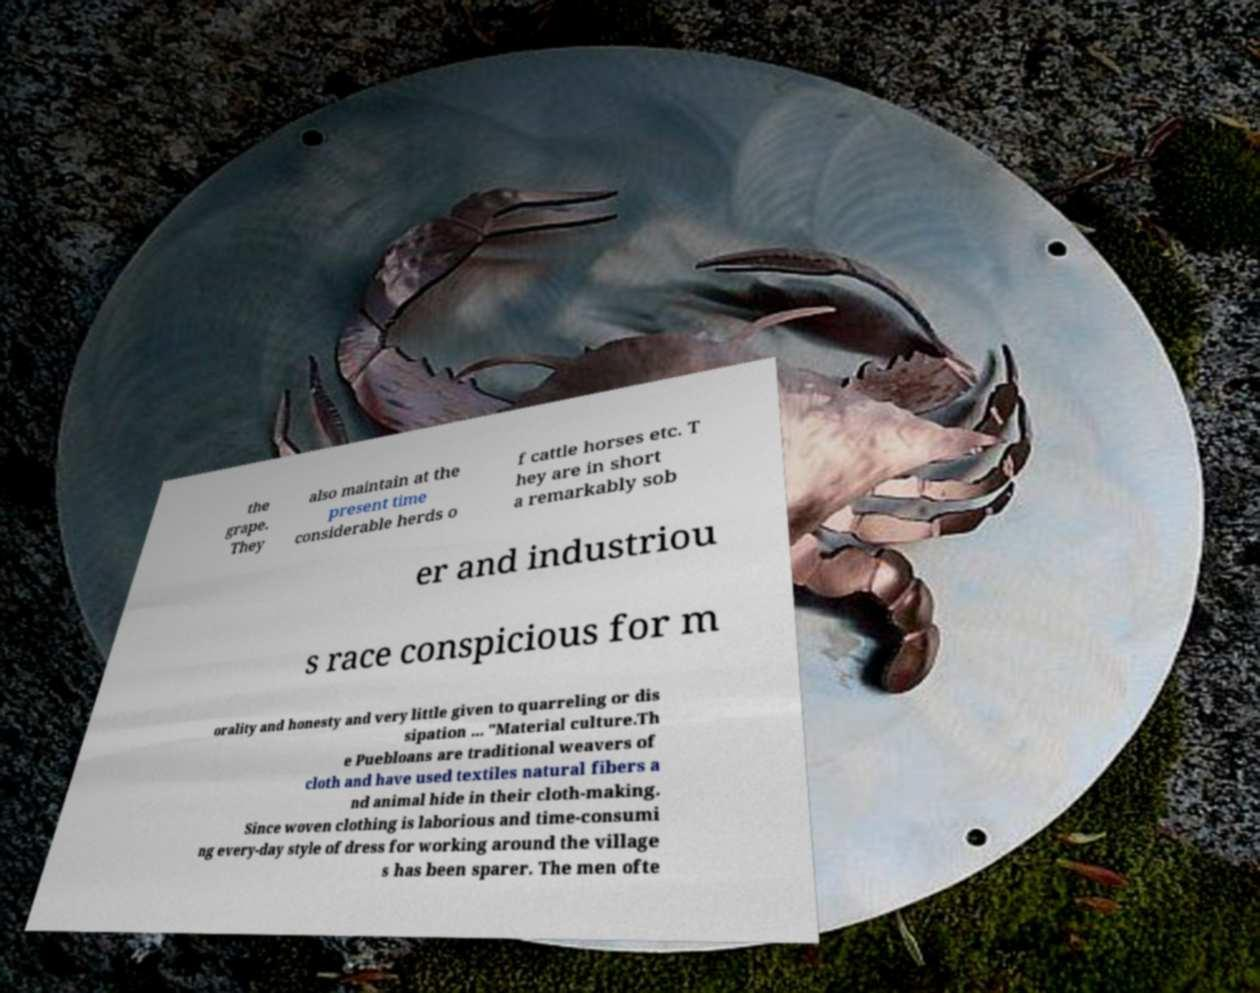There's text embedded in this image that I need extracted. Can you transcribe it verbatim? the grape. They also maintain at the present time considerable herds o f cattle horses etc. T hey are in short a remarkably sob er and industriou s race conspicious for m orality and honesty and very little given to quarreling or dis sipation ... "Material culture.Th e Puebloans are traditional weavers of cloth and have used textiles natural fibers a nd animal hide in their cloth-making. Since woven clothing is laborious and time-consumi ng every-day style of dress for working around the village s has been sparer. The men ofte 